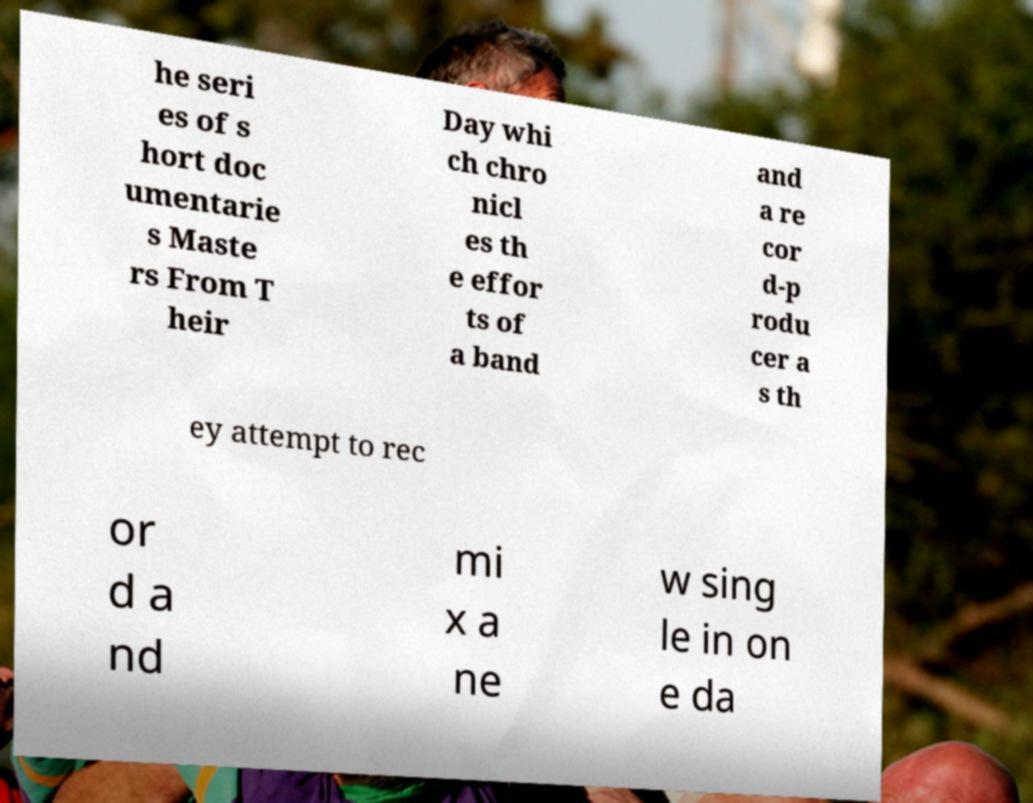Could you assist in decoding the text presented in this image and type it out clearly? he seri es of s hort doc umentarie s Maste rs From T heir Day whi ch chro nicl es th e effor ts of a band and a re cor d-p rodu cer a s th ey attempt to rec or d a nd mi x a ne w sing le in on e da 